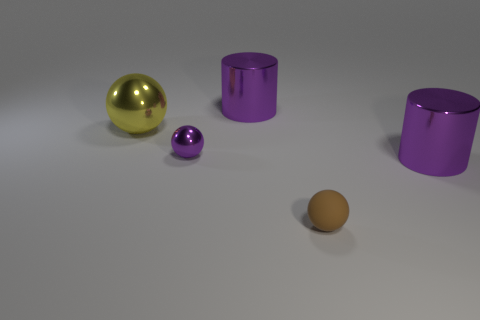Subtract 1 spheres. How many spheres are left? 2 Subtract all small matte spheres. How many spheres are left? 2 Add 2 brown balls. How many objects exist? 7 Subtract all spheres. How many objects are left? 2 Add 3 small spheres. How many small spheres exist? 5 Subtract 0 blue cylinders. How many objects are left? 5 Subtract all purple rubber spheres. Subtract all brown matte balls. How many objects are left? 4 Add 1 small purple metallic things. How many small purple metallic things are left? 2 